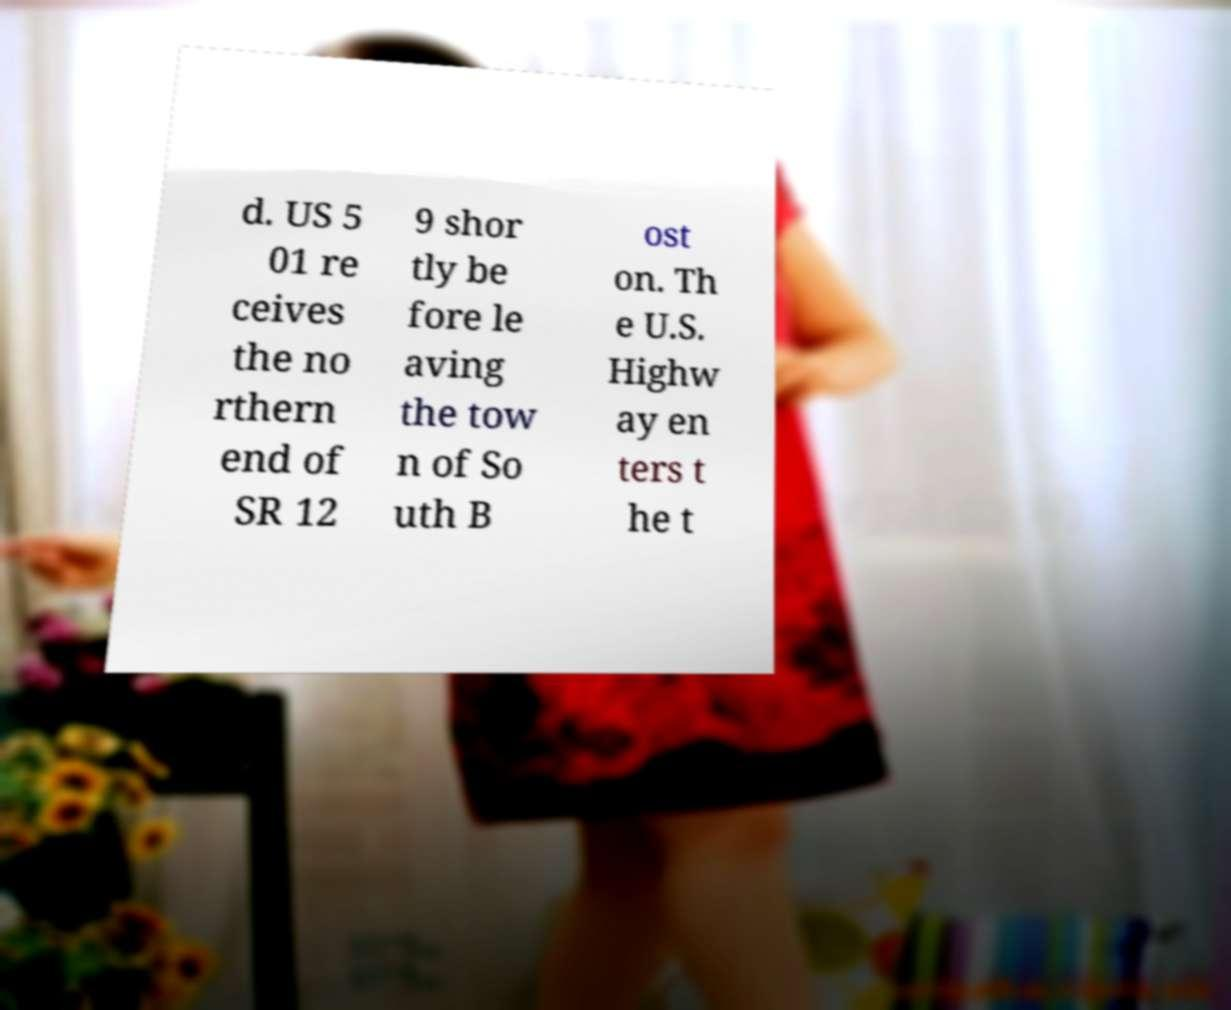Could you assist in decoding the text presented in this image and type it out clearly? d. US 5 01 re ceives the no rthern end of SR 12 9 shor tly be fore le aving the tow n of So uth B ost on. Th e U.S. Highw ay en ters t he t 